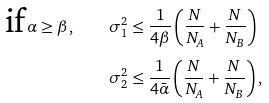Convert formula to latex. <formula><loc_0><loc_0><loc_500><loc_500>\text {if} \, \alpha \geq \beta , \quad \sigma ^ { 2 } _ { 1 } & \leq \frac { 1 } { 4 \beta } \left ( \frac { N } { N _ { A } } + \frac { N } { N _ { B } } \right ) \\ \quad \sigma ^ { 2 } _ { 2 } & \leq \frac { 1 } { 4 \bar { \alpha } } \left ( \frac { N } { N _ { A } } + \frac { N } { N _ { B } } \right ) ,</formula> 